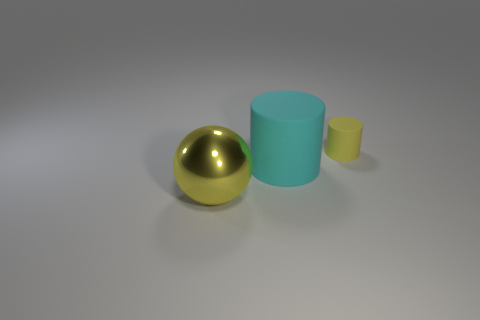Are there any other things that are the same size as the yellow cylinder?
Your answer should be compact. No. Is there a cylinder that has the same material as the cyan thing?
Make the answer very short. Yes. Is the number of yellow spheres that are to the left of the big yellow metal ball greater than the number of large cyan matte things that are to the left of the cyan matte cylinder?
Make the answer very short. No. Do the cyan rubber cylinder and the yellow matte object have the same size?
Your response must be concise. No. What color is the thing that is behind the large thing right of the yellow ball?
Provide a short and direct response. Yellow. What is the color of the small matte cylinder?
Offer a terse response. Yellow. Are there any other objects that have the same color as the tiny object?
Your answer should be compact. Yes. Does the matte thing behind the cyan rubber cylinder have the same color as the metallic ball?
Offer a very short reply. Yes. What number of objects are either big things to the right of the big yellow sphere or large yellow balls?
Your answer should be compact. 2. There is a big cyan matte cylinder; are there any big metallic things left of it?
Provide a short and direct response. Yes. 